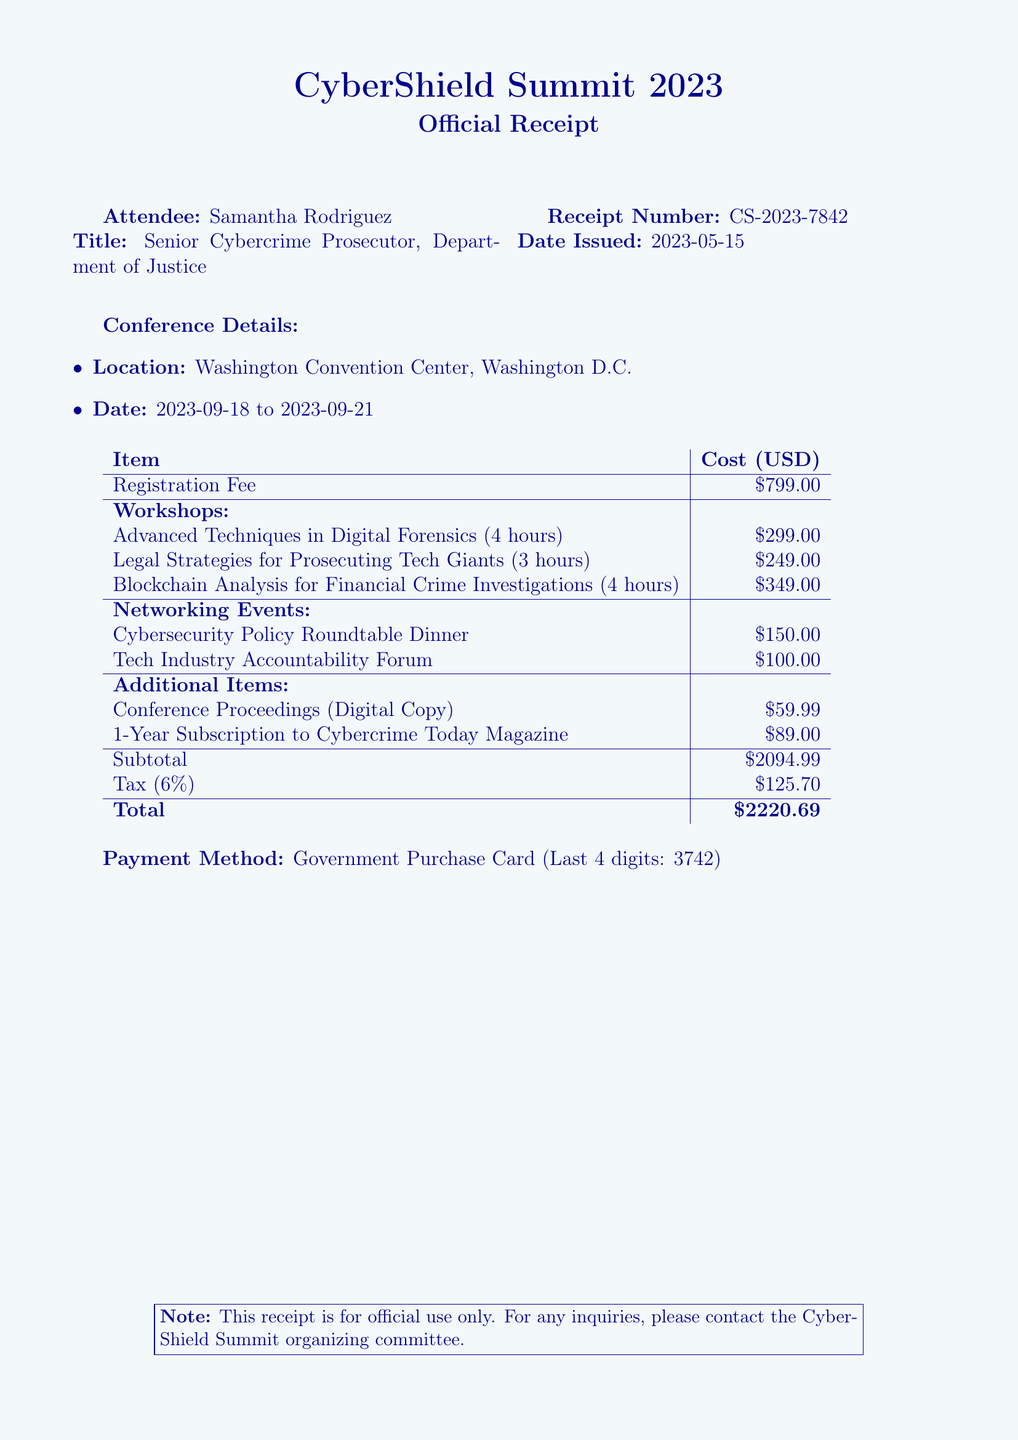What is the name of the conference? The name of the conference is stated at the top of the document.
Answer: CyberShield Summit 2023 Who is the attendee? The attendee's name is listed under the attendee information section.
Answer: Samantha Rodriguez What was the date the receipt was issued? The date issued is specified in the receipt details.
Answer: 2023-05-15 What is the total amount paid? The total amount appears in the final section of the receipt.
Answer: $2220.69 How many workshops are included in the registration? The number of workshops can be counted from the itemized workshop section.
Answer: 3 What is the cost of the workshop on "Legal Strategies for Prosecuting Tech Giants"? The cost is listed in the workshop fees section.
Answer: $249.00 What method of payment was used? The payment method is mentioned near the bottom of the receipt.
Answer: Government Purchase Card Where is the Cybersecurity Policy Roundtable Dinner taking place? The venue is indicated in the networking events section.
Answer: National Press Club What is the duration of the workshop taught by Dr. Marcus Chen? The duration is provided alongside the workshop details.
Answer: 4 hours What is the tax rate applied to the subtotal? The tax rate is specified in the tax section of the receipt.
Answer: 6% 